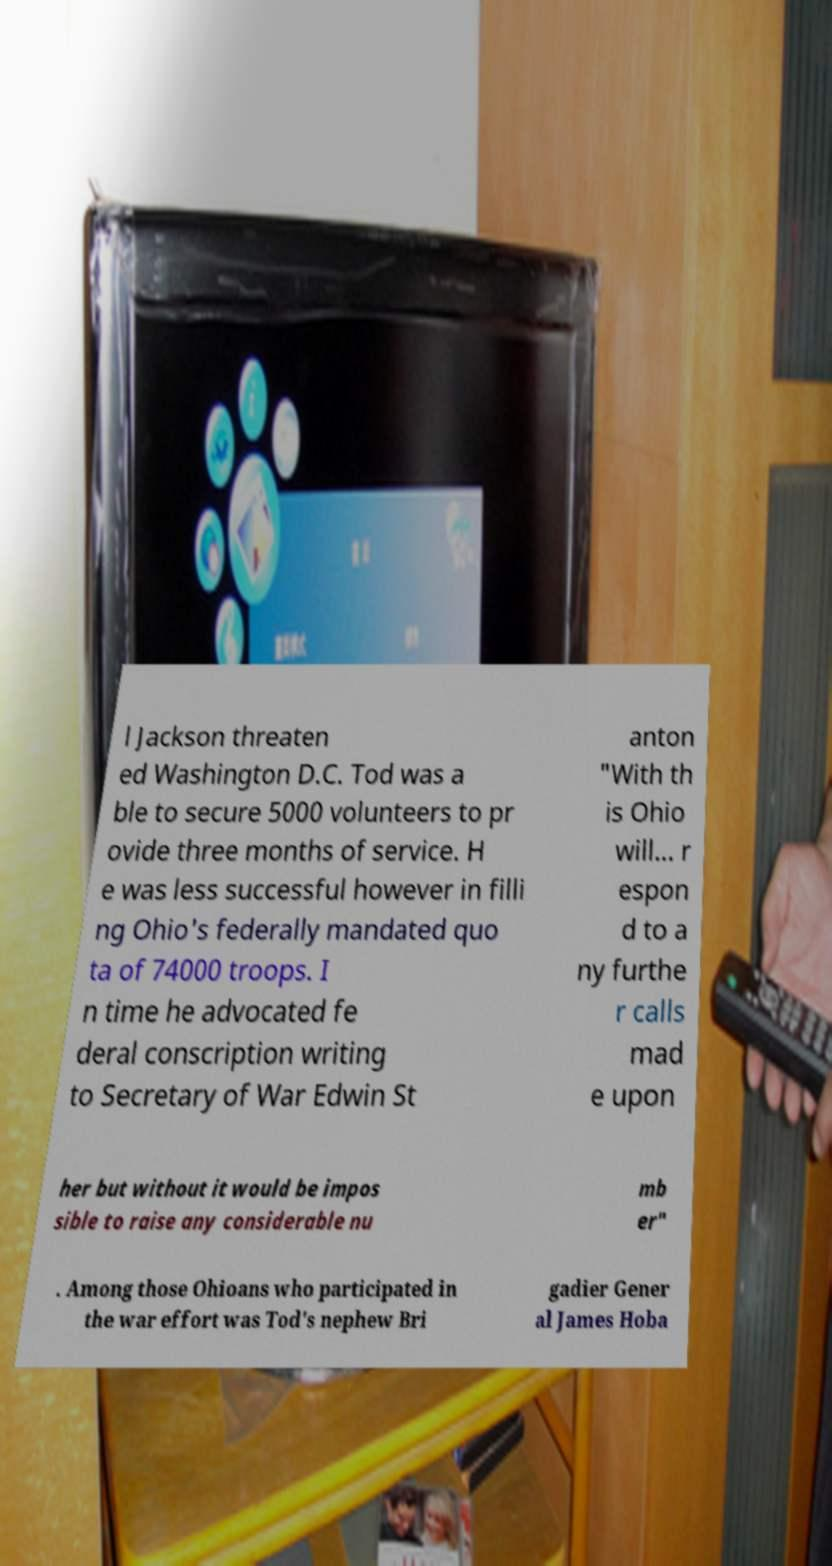I need the written content from this picture converted into text. Can you do that? l Jackson threaten ed Washington D.C. Tod was a ble to secure 5000 volunteers to pr ovide three months of service. H e was less successful however in filli ng Ohio's federally mandated quo ta of 74000 troops. I n time he advocated fe deral conscription writing to Secretary of War Edwin St anton "With th is Ohio will... r espon d to a ny furthe r calls mad e upon her but without it would be impos sible to raise any considerable nu mb er" . Among those Ohioans who participated in the war effort was Tod's nephew Bri gadier Gener al James Hoba 